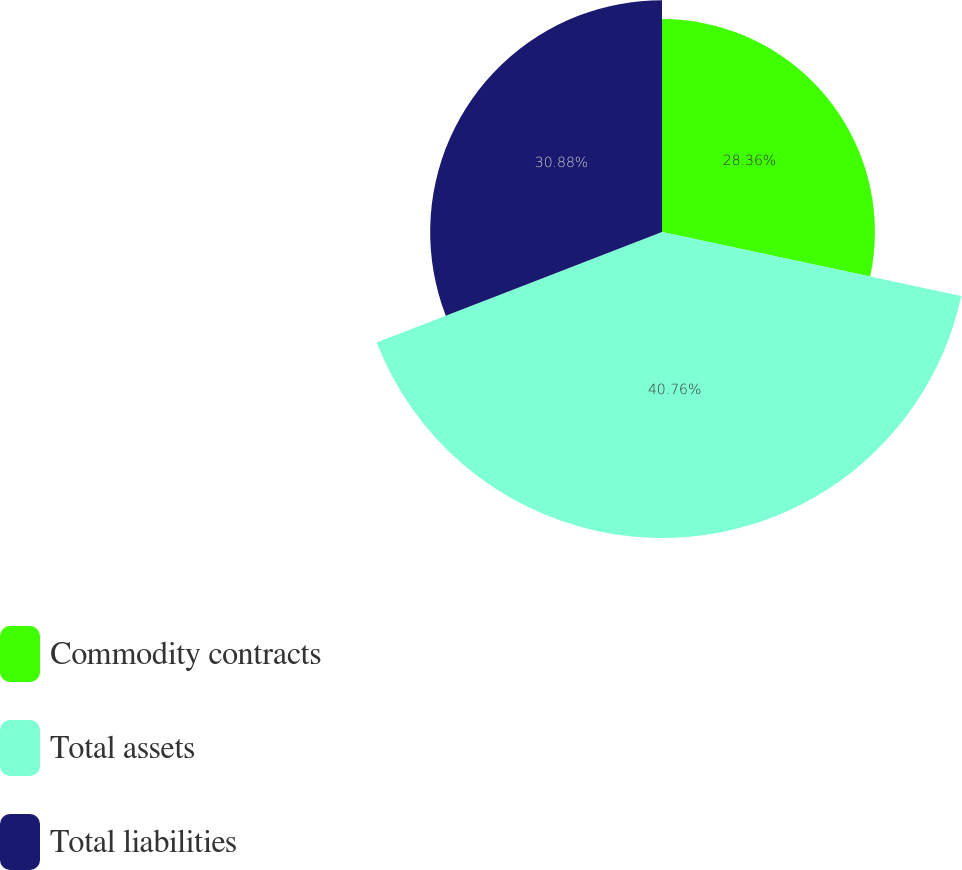Convert chart. <chart><loc_0><loc_0><loc_500><loc_500><pie_chart><fcel>Commodity contracts<fcel>Total assets<fcel>Total liabilities<nl><fcel>28.36%<fcel>40.76%<fcel>30.88%<nl></chart> 